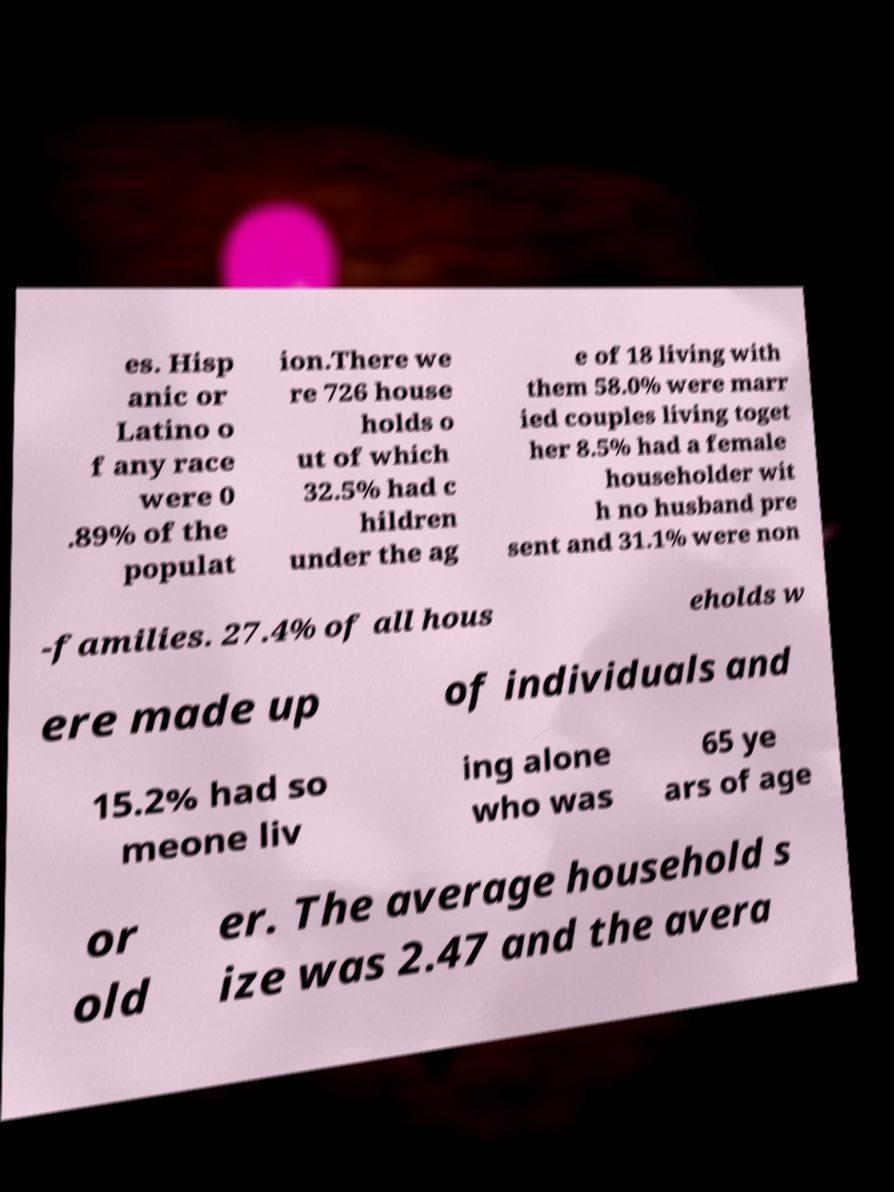I need the written content from this picture converted into text. Can you do that? es. Hisp anic or Latino o f any race were 0 .89% of the populat ion.There we re 726 house holds o ut of which 32.5% had c hildren under the ag e of 18 living with them 58.0% were marr ied couples living toget her 8.5% had a female householder wit h no husband pre sent and 31.1% were non -families. 27.4% of all hous eholds w ere made up of individuals and 15.2% had so meone liv ing alone who was 65 ye ars of age or old er. The average household s ize was 2.47 and the avera 